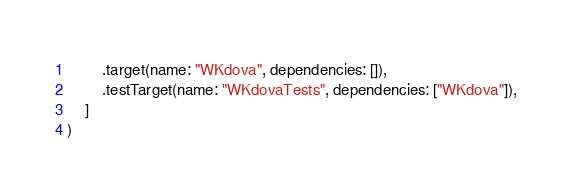<code> <loc_0><loc_0><loc_500><loc_500><_Swift_>        .target(name: "WKdova", dependencies: []),
        .testTarget(name: "WKdovaTests", dependencies: ["WKdova"]),
    ]
)
</code> 